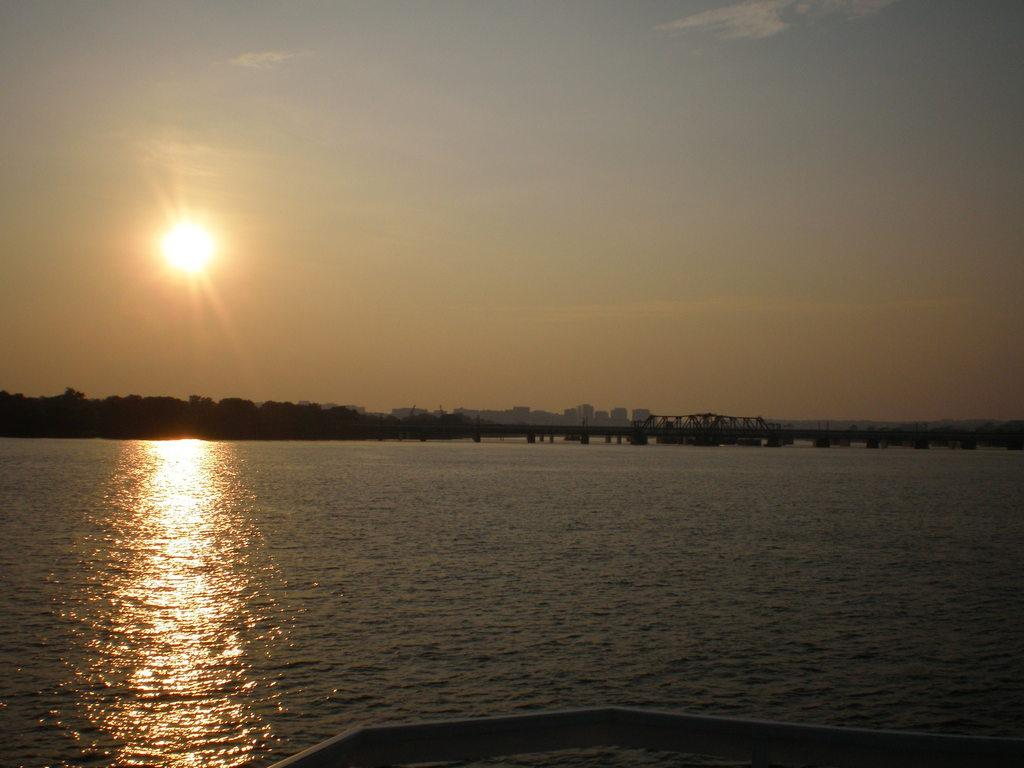What is located at the bottom of the image? There is an object at the bottom of the image. What can be seen in the background of the image? The sky, the sun, buildings, a bridge, water, and other unspecified objects are visible in the background of the image. What type of acoustics can be heard from the bridge in the image? There is no information about the acoustics of the bridge in the image, as it only provides visual details. 